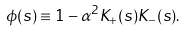<formula> <loc_0><loc_0><loc_500><loc_500>\phi ( s ) \equiv 1 - \alpha ^ { 2 } K _ { + } ( s ) K _ { - } ( s ) .</formula> 